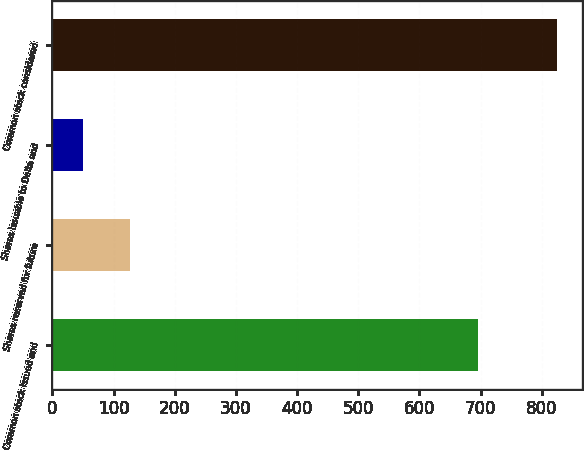<chart> <loc_0><loc_0><loc_500><loc_500><bar_chart><fcel>Common stock issued and<fcel>Shares reserved for future<fcel>Shares issuable to Delta and<fcel>Common stock considered<nl><fcel>695<fcel>127.5<fcel>50<fcel>825<nl></chart> 